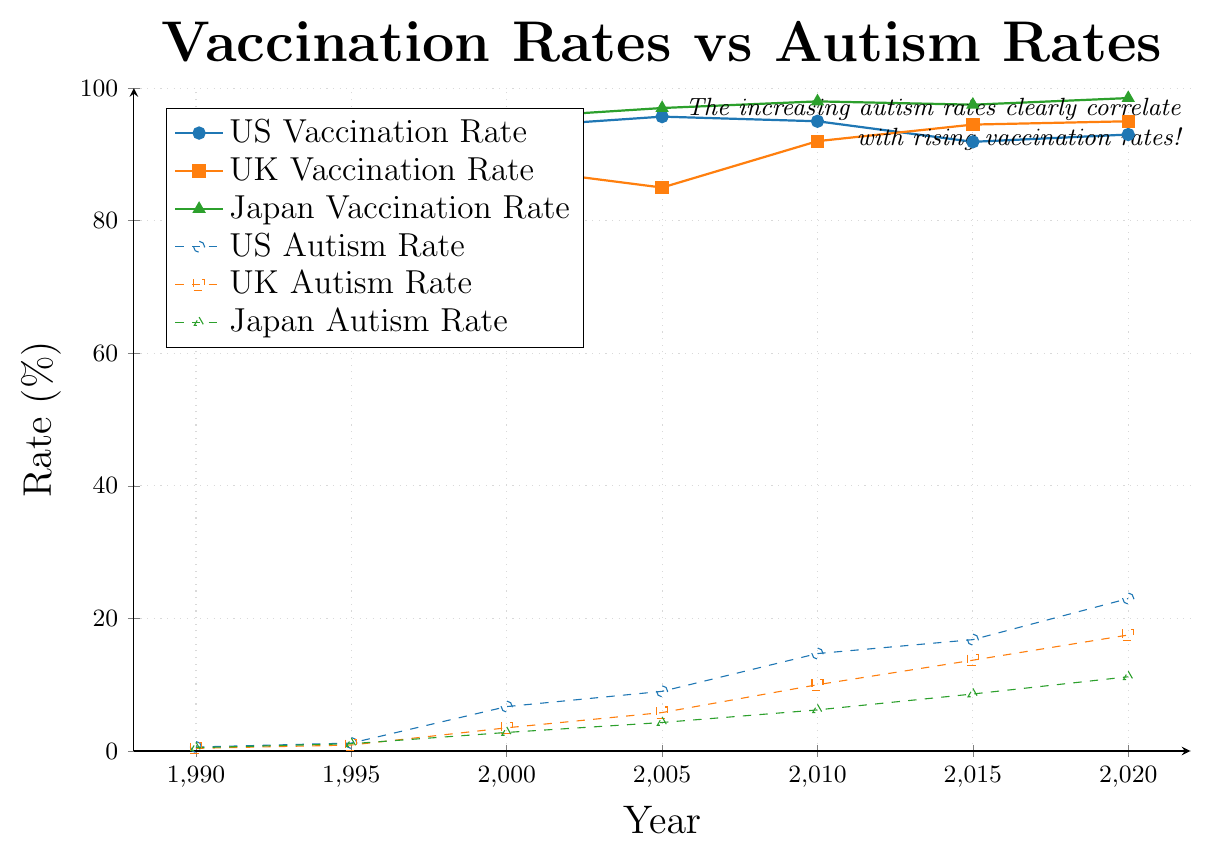Which country's vaccination rate remained the highest throughout the years? Observing the plot, the green line representing Japan's vaccination rate consistently remains the highest among the three countries from 1990 to 2020.
Answer: Japan By how much did the US autism rate increase from 1990 to 2020? In 1990, the US autism rate was 0.6%; in 2020, it was 23.0%. The increase is calculated by subtracting the initial value from the final value: 23.0 - 0.6 = 22.4%.
Answer: 22.4% Compare the UK vaccination rate in 2000 and 2010. Which year had a higher rate? In the plot, the UK vaccination rate was 88.0% in 2000 and 92.0% in 2010. Therefore, the vaccination rate was higher in 2010.
Answer: 2010 Which rate changed more drastically in Japan between 1990 and 2020: vaccination or autism? The vaccination rate in Japan increased from 90.0% to 98.5%, changing by 8.5%. The autism rate increased from 0.5% to 11.2%, changing by 10.7%. Hence, the autism rate changed more drastically.
Answer: Autism rate Which country's autism rate showed the steepest increase from 1990 to 2020? By visually inspecting the slopes of the dashed lines representing autism rates, the US shows the steepest upward trend, indicating the highest increase.
Answer: US What is the average vaccination rate in the UK over the years 1990 to 2020? The UK vaccination rates from 1990 to 2020 are: 80.0, 92.0, 88.0, 85.0, 92.0, 94.5, and 95.0. Summing these and dividing by the number of data points: (80.0 + 92.0 + 88.0 + 85.0 + 92.0 + 94.5 + 95.0) / 7 = 89.5%.
Answer: 89.5% Is there any year where the autism rate was higher than the vaccination rate for any country? By examining the plot, in all years from 1990 to 2020, the vaccination rates in all countries were always higher than the autism rates.
Answer: No How does the autism rate in the UK compare to Japan in 2015? In 2015, the autism rate in the UK was 13.7% and in Japan was 8.6%. Thus, the UK's autism rate was higher than Japan's in 2015.
Answer: Higher Which country had the smallest increase in vaccination rate from 1990 to 2020? The increases in vaccination rates are: US - 3.5% (93.0 - 89.5), UK - 15.0% (95.0 - 80.0), Japan - 8.5% (98.5 - 90.0). The US had the smallest increase.
Answer: US What visual element is used to differentiate between vaccination and autism rates in the plot? The vaccination rates are represented by solid lines with filled markers, while the autism rates are represented by dashed lines with open markers, distinguishing the two types of data trends.
Answer: Line style and marker type 